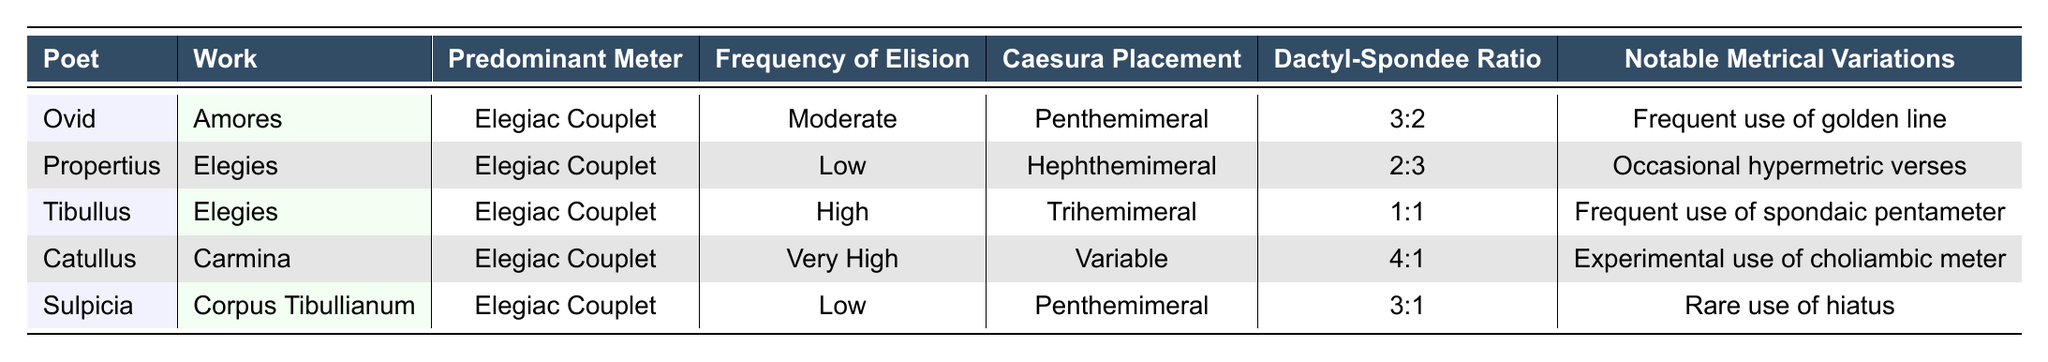What is the predominant meter used by Catullus in his work "Carmina"? The table shows that the predominant meter for Catullus in "Carmina" is "Elegiac Couplet." Therefore, we can directly retrieve this information from the corresponding row.
Answer: Elegiac Couplet Which poet has the highest frequency of elision? In the table, Catullus has the highest frequency of elision listed as "Very High." We can compare the frequency levels for all poets and confirm that Catullus stands out in this regard.
Answer: Catullus What is the dactyl-spondee ratio for Propertius? The dactyl-spondee ratio for Propertius can be found in the table under his corresponding row, showing it as "2:3."
Answer: 2:3 Do any of the poets have a low frequency of elision? Yes, both Propertius and Sulpicia have a low frequency of elision according to the table, as their frequency levels are listed under the "Frequency of Elision" column.
Answer: Yes Which poet uses a frequency of elision rated as "Moderate"? Referring to the table, Ovid has a frequency of elision classified as "Moderate." We identify this by checking the "Frequency of Elision" of Ovid’s row.
Answer: Ovid How many poets use a caesura placement of "Penthemimeral"? By examining the table, we see that both Ovid and Sulpicia have a caesura placement listed as "Penthemimeral," indicating 2 poets use this placement.
Answer: 2 poets Is there a poet who uses "frequent use of golden line"? Yes, the table states that Ovid is noted for frequent use of the golden line in the "Notable Metrical Variations" column. We can verify this in his row.
Answer: Yes What is the dactyl-spondee ratio for Tibullus, and how does it compare to that of Catullus? Tibullus has a dactyl-spondee ratio of "1:1" while Catullus has a ratio of "4:1." When comparing, we see that Catullus’s ratio has more dactyls relative to spondees than Tibullus.
Answer: Tibullus: 1:1, Catullus: 4:1 Which poet has a notable metrical variation that includes rare use of hiatus? The table shows that Sulpicia has a notable variation described as rare use of hiatus. This information can be found in her corresponding row under the last column.
Answer: Sulpicia 